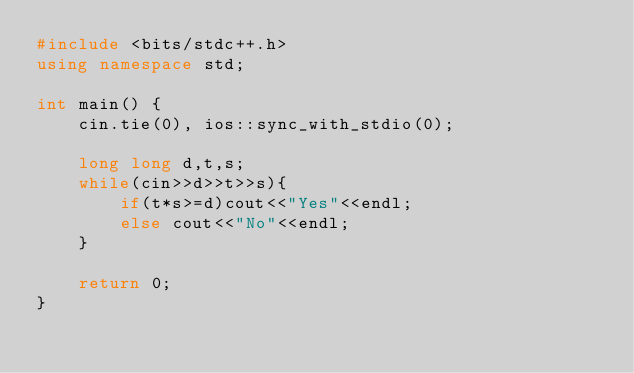Convert code to text. <code><loc_0><loc_0><loc_500><loc_500><_C++_>#include <bits/stdc++.h>
using namespace std;

int main() {
    cin.tie(0), ios::sync_with_stdio(0);
    
    long long d,t,s;
    while(cin>>d>>t>>s){
        if(t*s>=d)cout<<"Yes"<<endl;
        else cout<<"No"<<endl;
    }
    
    return 0;
}</code> 